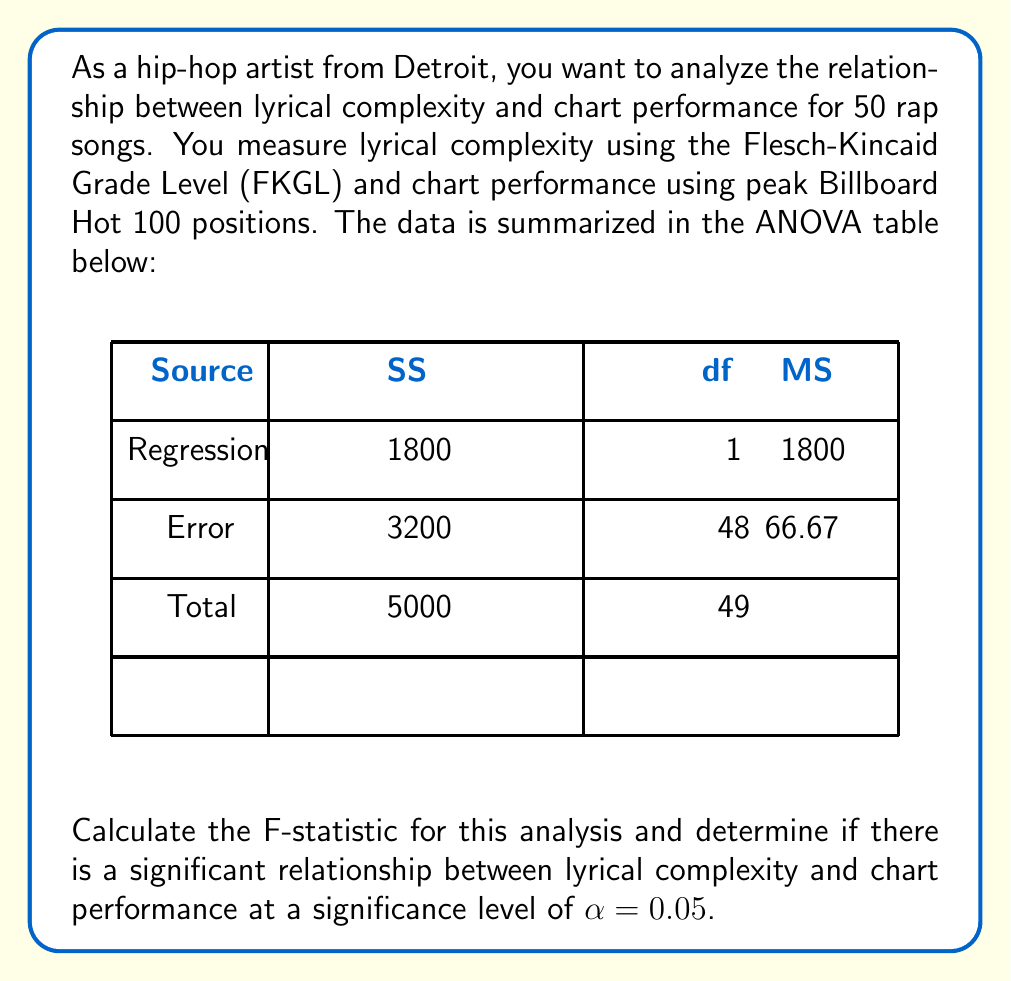Could you help me with this problem? To determine if there's a significant relationship between lyrical complexity and chart performance, we need to calculate the F-statistic and compare it to the critical F-value.

Step 1: Calculate the F-statistic
The F-statistic is the ratio of the Mean Square Regression (MSR) to the Mean Square Error (MSE).

$$F = \frac{MSR}{MSE}$$

From the ANOVA table:
MSR = 1800
MSE = 66.67

$$F = \frac{1800}{66.67} = 27$$

Step 2: Determine the degrees of freedom
From the ANOVA table:
df(regression) = 1
df(error) = 48

Step 3: Find the critical F-value
For α = 0.05, df(numerator) = 1, and df(denominator) = 48, the critical F-value is approximately 4.04 (This can be found in an F-distribution table or using statistical software).

Step 4: Compare the F-statistic to the critical F-value
Since 27 > 4.04, we reject the null hypothesis.

Step 5: Interpret the results
The F-statistic (27) is greater than the critical F-value (4.04), indicating a statistically significant relationship between lyrical complexity and chart performance at the 0.05 significance level.
Answer: F(1,48) = 27, p < 0.05 